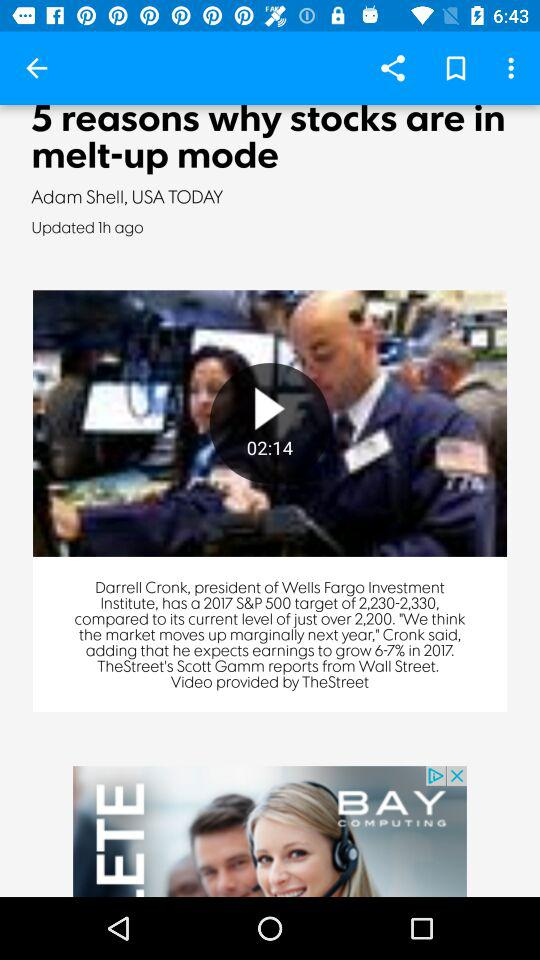Which applications are available for sharing the article?
When the provided information is insufficient, respond with <no answer>. <no answer> 